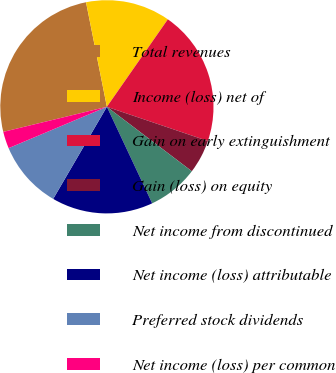Convert chart to OTSL. <chart><loc_0><loc_0><loc_500><loc_500><pie_chart><fcel>Total revenues<fcel>Income (loss) net of<fcel>Gain on early extinguishment<fcel>Gain (loss) on equity<fcel>Net income from discontinued<fcel>Net income (loss) attributable<fcel>Preferred stock dividends<fcel>Net income (loss) per common<nl><fcel>25.64%<fcel>12.82%<fcel>20.51%<fcel>5.13%<fcel>7.69%<fcel>15.38%<fcel>10.26%<fcel>2.56%<nl></chart> 